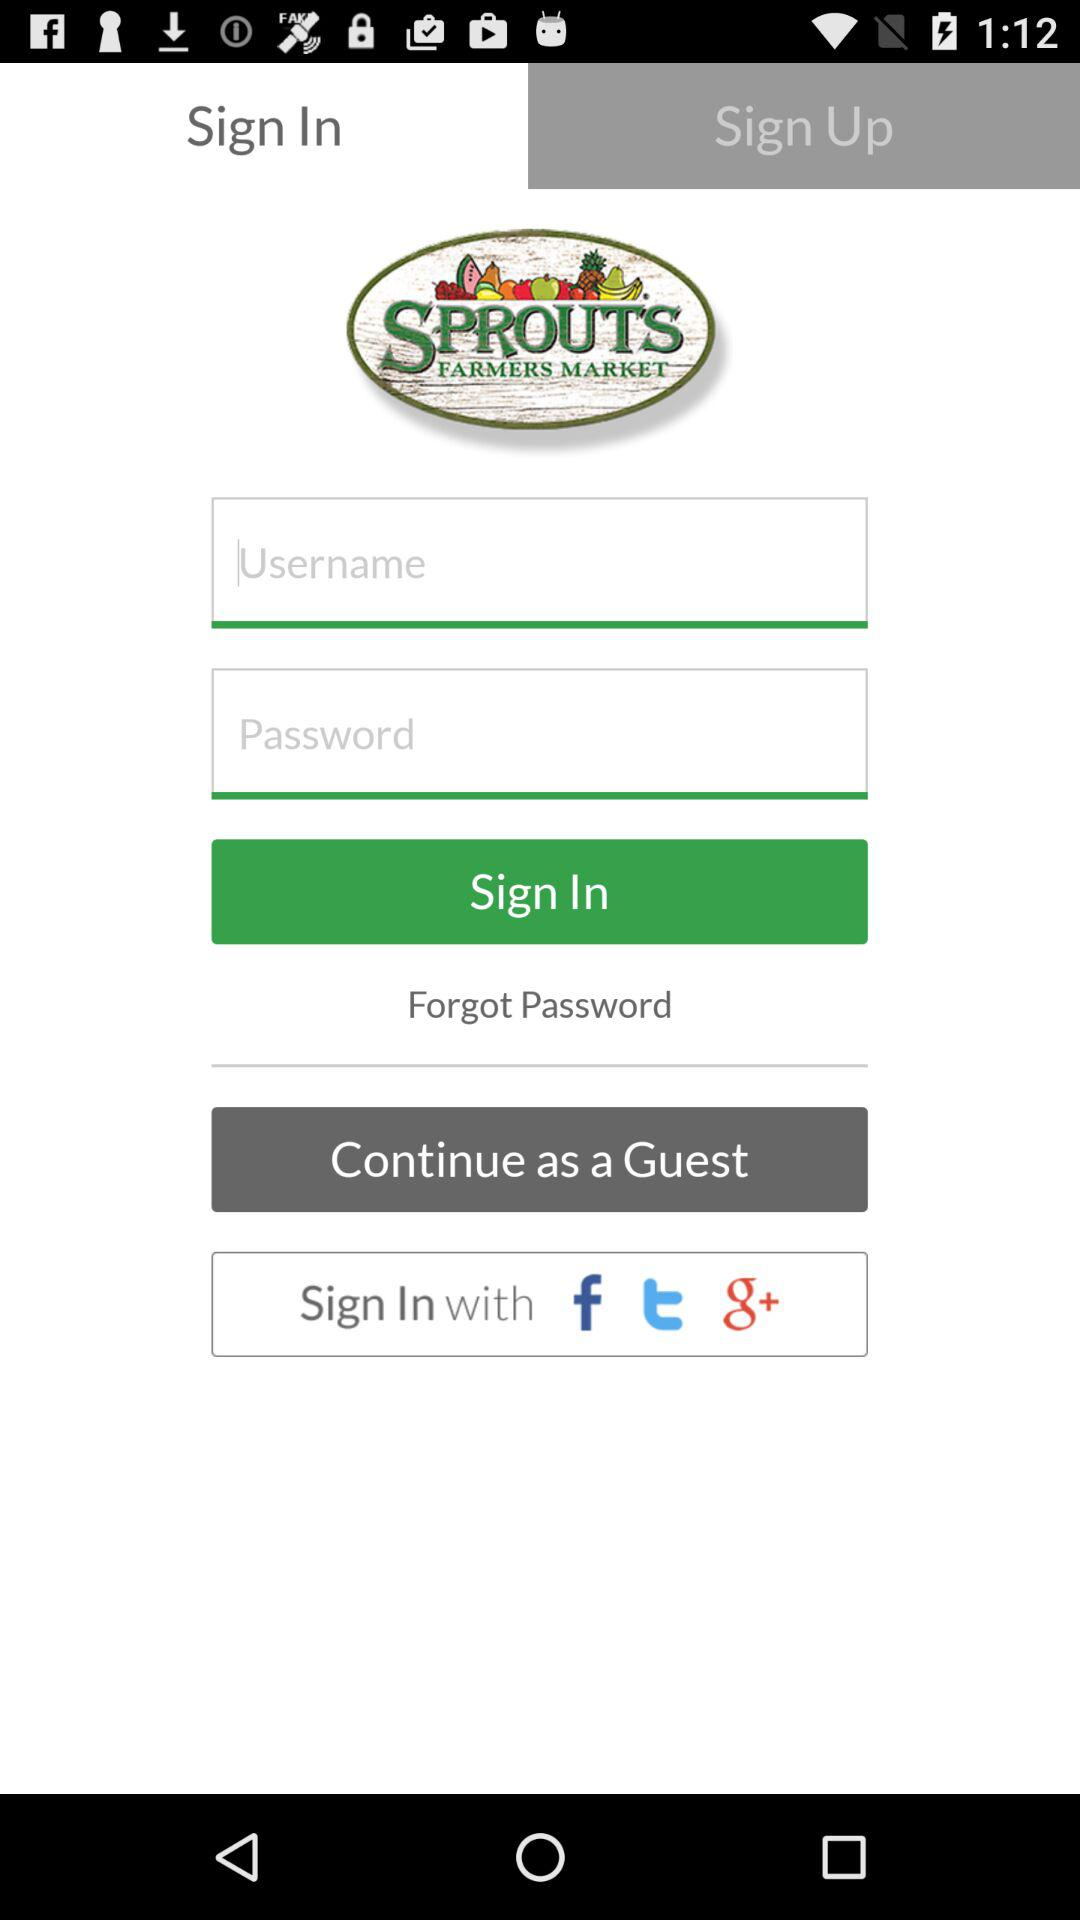What is the app name? The app name is "SPROUTS FARMERS MARKET". 